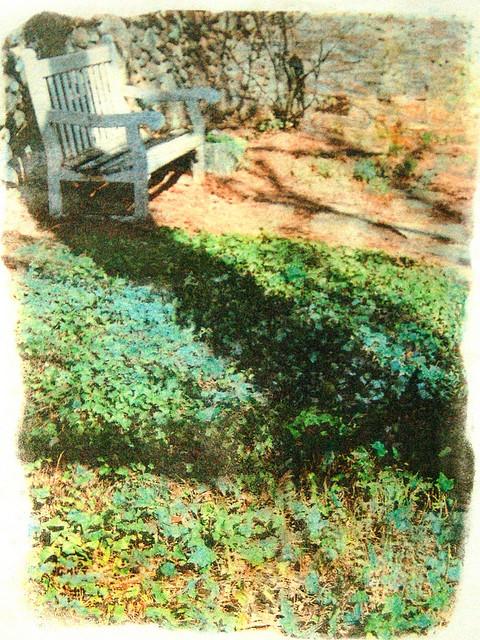What is the bench made of?
Keep it brief. Wood. What color is the bench?
Short answer required. White. What plant is covering the ground?
Give a very brief answer. Ivy. 